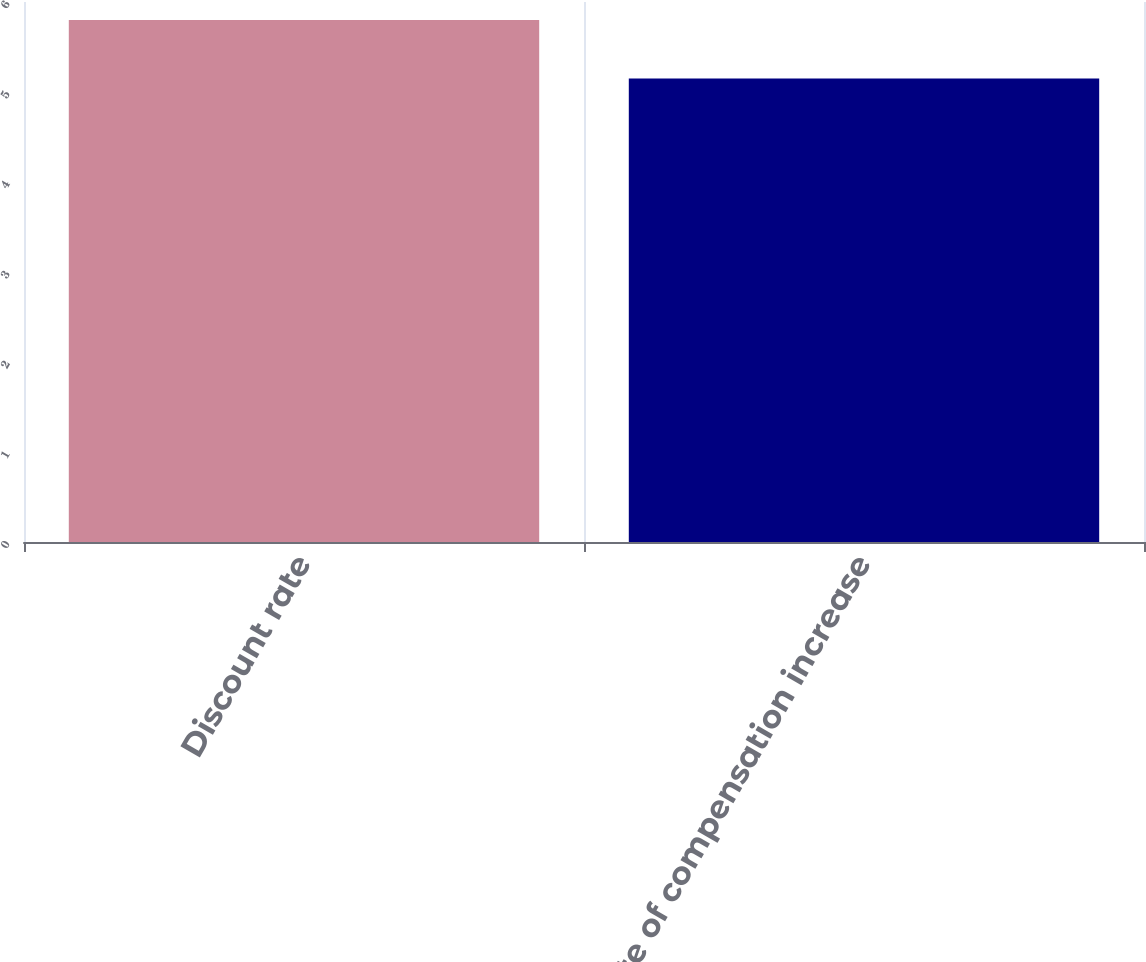<chart> <loc_0><loc_0><loc_500><loc_500><bar_chart><fcel>Discount rate<fcel>Rate of compensation increase<nl><fcel>5.8<fcel>5.15<nl></chart> 